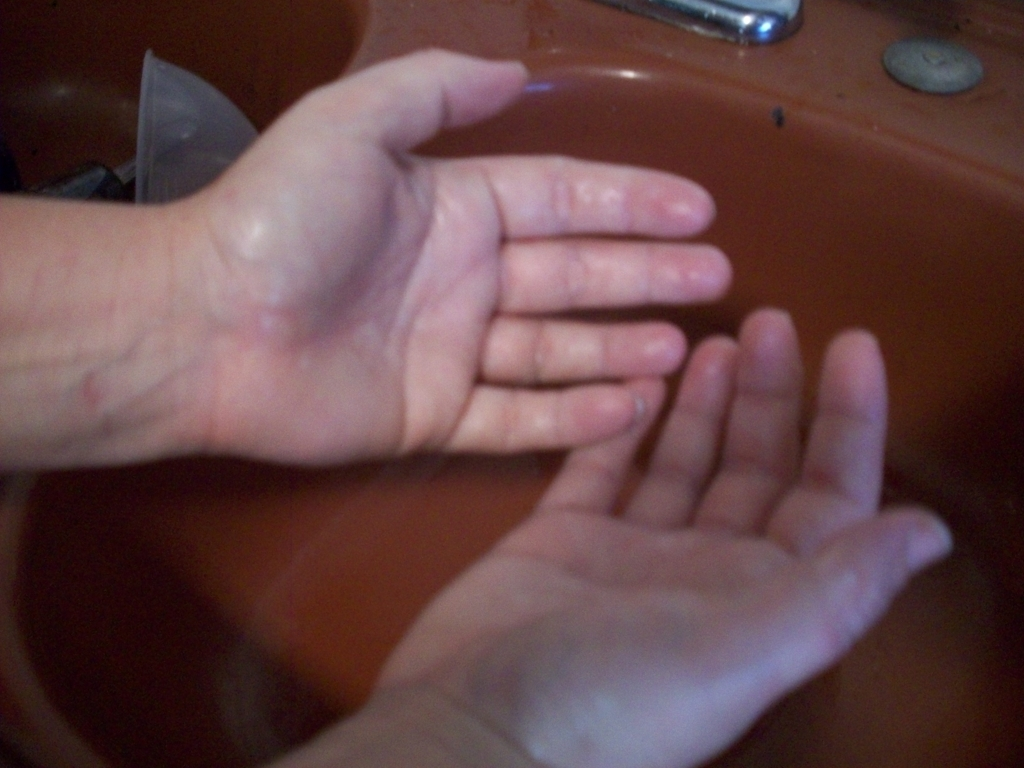What is the person doing in this photograph? The person in the photograph appears to be washing their hands under a stream of water, likely for hygiene purposes. Why is hand washing important? Hand washing is crucial for removing germs and preventing the spread of infections. It is one of the most effective ways to maintain good personal hygiene and public health. 